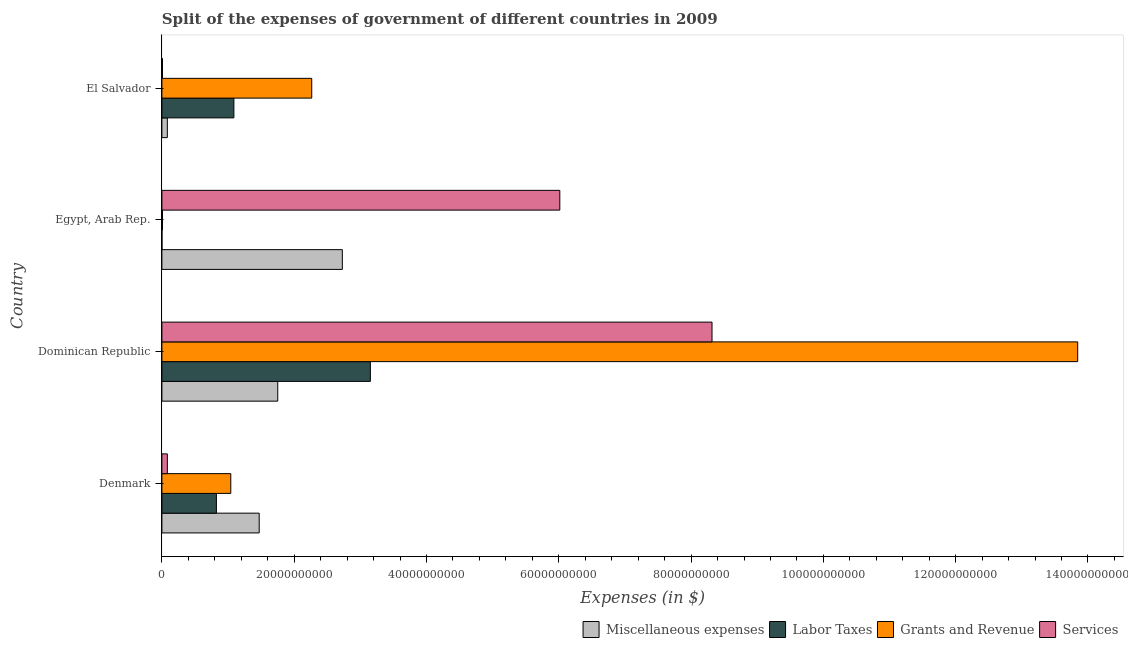How many groups of bars are there?
Make the answer very short. 4. Are the number of bars on each tick of the Y-axis equal?
Give a very brief answer. Yes. How many bars are there on the 2nd tick from the top?
Provide a short and direct response. 4. How many bars are there on the 2nd tick from the bottom?
Make the answer very short. 4. What is the label of the 2nd group of bars from the top?
Offer a very short reply. Egypt, Arab Rep. What is the amount spent on services in Dominican Republic?
Your answer should be very brief. 8.32e+1. Across all countries, what is the maximum amount spent on grants and revenue?
Give a very brief answer. 1.38e+11. Across all countries, what is the minimum amount spent on services?
Keep it short and to the point. 8.44e+07. In which country was the amount spent on services maximum?
Your answer should be compact. Dominican Republic. In which country was the amount spent on labor taxes minimum?
Your answer should be very brief. Egypt, Arab Rep. What is the total amount spent on services in the graph?
Your answer should be compact. 1.44e+11. What is the difference between the amount spent on grants and revenue in Denmark and that in El Salvador?
Make the answer very short. -1.22e+1. What is the difference between the amount spent on services in Dominican Republic and the amount spent on miscellaneous expenses in El Salvador?
Make the answer very short. 8.23e+1. What is the average amount spent on grants and revenue per country?
Keep it short and to the point. 4.29e+1. What is the difference between the amount spent on grants and revenue and amount spent on miscellaneous expenses in Denmark?
Keep it short and to the point. -4.30e+09. What is the ratio of the amount spent on grants and revenue in Dominican Republic to that in Egypt, Arab Rep.?
Your response must be concise. 1518.04. Is the amount spent on services in Denmark less than that in El Salvador?
Offer a terse response. No. What is the difference between the highest and the second highest amount spent on labor taxes?
Offer a terse response. 2.06e+1. What is the difference between the highest and the lowest amount spent on miscellaneous expenses?
Offer a terse response. 2.65e+1. In how many countries, is the amount spent on miscellaneous expenses greater than the average amount spent on miscellaneous expenses taken over all countries?
Give a very brief answer. 2. Is the sum of the amount spent on services in Denmark and El Salvador greater than the maximum amount spent on miscellaneous expenses across all countries?
Your response must be concise. No. Is it the case that in every country, the sum of the amount spent on grants and revenue and amount spent on services is greater than the sum of amount spent on labor taxes and amount spent on miscellaneous expenses?
Your response must be concise. No. What does the 1st bar from the top in Denmark represents?
Your answer should be compact. Services. What does the 2nd bar from the bottom in Dominican Republic represents?
Provide a succinct answer. Labor Taxes. What is the difference between two consecutive major ticks on the X-axis?
Your answer should be compact. 2.00e+1. Does the graph contain any zero values?
Provide a succinct answer. No. Does the graph contain grids?
Provide a succinct answer. No. Where does the legend appear in the graph?
Make the answer very short. Bottom right. How are the legend labels stacked?
Your response must be concise. Horizontal. What is the title of the graph?
Your response must be concise. Split of the expenses of government of different countries in 2009. Does "Overall level" appear as one of the legend labels in the graph?
Provide a short and direct response. No. What is the label or title of the X-axis?
Make the answer very short. Expenses (in $). What is the label or title of the Y-axis?
Make the answer very short. Country. What is the Expenses (in $) in Miscellaneous expenses in Denmark?
Offer a very short reply. 1.47e+1. What is the Expenses (in $) in Labor Taxes in Denmark?
Your answer should be compact. 8.24e+09. What is the Expenses (in $) of Grants and Revenue in Denmark?
Ensure brevity in your answer.  1.04e+1. What is the Expenses (in $) in Services in Denmark?
Provide a short and direct response. 8.23e+08. What is the Expenses (in $) of Miscellaneous expenses in Dominican Republic?
Give a very brief answer. 1.75e+1. What is the Expenses (in $) in Labor Taxes in Dominican Republic?
Make the answer very short. 3.15e+1. What is the Expenses (in $) of Grants and Revenue in Dominican Republic?
Provide a succinct answer. 1.38e+11. What is the Expenses (in $) in Services in Dominican Republic?
Offer a terse response. 8.32e+1. What is the Expenses (in $) in Miscellaneous expenses in Egypt, Arab Rep.?
Give a very brief answer. 2.73e+1. What is the Expenses (in $) of Labor Taxes in Egypt, Arab Rep.?
Provide a succinct answer. 9.10e+06. What is the Expenses (in $) of Grants and Revenue in Egypt, Arab Rep.?
Provide a succinct answer. 9.12e+07. What is the Expenses (in $) in Services in Egypt, Arab Rep.?
Provide a short and direct response. 6.02e+1. What is the Expenses (in $) in Miscellaneous expenses in El Salvador?
Provide a succinct answer. 8.19e+08. What is the Expenses (in $) in Labor Taxes in El Salvador?
Provide a short and direct response. 1.09e+1. What is the Expenses (in $) of Grants and Revenue in El Salvador?
Keep it short and to the point. 2.26e+1. What is the Expenses (in $) in Services in El Salvador?
Ensure brevity in your answer.  8.44e+07. Across all countries, what is the maximum Expenses (in $) of Miscellaneous expenses?
Offer a terse response. 2.73e+1. Across all countries, what is the maximum Expenses (in $) of Labor Taxes?
Make the answer very short. 3.15e+1. Across all countries, what is the maximum Expenses (in $) in Grants and Revenue?
Give a very brief answer. 1.38e+11. Across all countries, what is the maximum Expenses (in $) of Services?
Keep it short and to the point. 8.32e+1. Across all countries, what is the minimum Expenses (in $) in Miscellaneous expenses?
Give a very brief answer. 8.19e+08. Across all countries, what is the minimum Expenses (in $) of Labor Taxes?
Your answer should be very brief. 9.10e+06. Across all countries, what is the minimum Expenses (in $) of Grants and Revenue?
Give a very brief answer. 9.12e+07. Across all countries, what is the minimum Expenses (in $) in Services?
Your answer should be compact. 8.44e+07. What is the total Expenses (in $) in Miscellaneous expenses in the graph?
Make the answer very short. 6.03e+1. What is the total Expenses (in $) in Labor Taxes in the graph?
Keep it short and to the point. 5.06e+1. What is the total Expenses (in $) in Grants and Revenue in the graph?
Offer a terse response. 1.72e+11. What is the total Expenses (in $) in Services in the graph?
Provide a succinct answer. 1.44e+11. What is the difference between the Expenses (in $) in Miscellaneous expenses in Denmark and that in Dominican Republic?
Offer a very short reply. -2.80e+09. What is the difference between the Expenses (in $) of Labor Taxes in Denmark and that in Dominican Republic?
Give a very brief answer. -2.33e+1. What is the difference between the Expenses (in $) of Grants and Revenue in Denmark and that in Dominican Republic?
Offer a terse response. -1.28e+11. What is the difference between the Expenses (in $) of Services in Denmark and that in Dominican Republic?
Give a very brief answer. -8.23e+1. What is the difference between the Expenses (in $) of Miscellaneous expenses in Denmark and that in Egypt, Arab Rep.?
Ensure brevity in your answer.  -1.26e+1. What is the difference between the Expenses (in $) of Labor Taxes in Denmark and that in Egypt, Arab Rep.?
Ensure brevity in your answer.  8.23e+09. What is the difference between the Expenses (in $) of Grants and Revenue in Denmark and that in Egypt, Arab Rep.?
Offer a terse response. 1.03e+1. What is the difference between the Expenses (in $) of Services in Denmark and that in Egypt, Arab Rep.?
Ensure brevity in your answer.  -5.93e+1. What is the difference between the Expenses (in $) in Miscellaneous expenses in Denmark and that in El Salvador?
Give a very brief answer. 1.39e+1. What is the difference between the Expenses (in $) of Labor Taxes in Denmark and that in El Salvador?
Keep it short and to the point. -2.64e+09. What is the difference between the Expenses (in $) of Grants and Revenue in Denmark and that in El Salvador?
Offer a terse response. -1.22e+1. What is the difference between the Expenses (in $) in Services in Denmark and that in El Salvador?
Your answer should be compact. 7.39e+08. What is the difference between the Expenses (in $) in Miscellaneous expenses in Dominican Republic and that in Egypt, Arab Rep.?
Keep it short and to the point. -9.76e+09. What is the difference between the Expenses (in $) of Labor Taxes in Dominican Republic and that in Egypt, Arab Rep.?
Your answer should be very brief. 3.15e+1. What is the difference between the Expenses (in $) in Grants and Revenue in Dominican Republic and that in Egypt, Arab Rep.?
Provide a short and direct response. 1.38e+11. What is the difference between the Expenses (in $) in Services in Dominican Republic and that in Egypt, Arab Rep.?
Your answer should be compact. 2.30e+1. What is the difference between the Expenses (in $) in Miscellaneous expenses in Dominican Republic and that in El Salvador?
Your answer should be very brief. 1.67e+1. What is the difference between the Expenses (in $) of Labor Taxes in Dominican Republic and that in El Salvador?
Your answer should be very brief. 2.06e+1. What is the difference between the Expenses (in $) of Grants and Revenue in Dominican Republic and that in El Salvador?
Your response must be concise. 1.16e+11. What is the difference between the Expenses (in $) in Services in Dominican Republic and that in El Salvador?
Ensure brevity in your answer.  8.31e+1. What is the difference between the Expenses (in $) of Miscellaneous expenses in Egypt, Arab Rep. and that in El Salvador?
Give a very brief answer. 2.65e+1. What is the difference between the Expenses (in $) of Labor Taxes in Egypt, Arab Rep. and that in El Salvador?
Offer a very short reply. -1.09e+1. What is the difference between the Expenses (in $) in Grants and Revenue in Egypt, Arab Rep. and that in El Salvador?
Your answer should be compact. -2.26e+1. What is the difference between the Expenses (in $) in Services in Egypt, Arab Rep. and that in El Salvador?
Your response must be concise. 6.01e+1. What is the difference between the Expenses (in $) of Miscellaneous expenses in Denmark and the Expenses (in $) of Labor Taxes in Dominican Republic?
Make the answer very short. -1.68e+1. What is the difference between the Expenses (in $) in Miscellaneous expenses in Denmark and the Expenses (in $) in Grants and Revenue in Dominican Republic?
Provide a short and direct response. -1.24e+11. What is the difference between the Expenses (in $) in Miscellaneous expenses in Denmark and the Expenses (in $) in Services in Dominican Republic?
Ensure brevity in your answer.  -6.85e+1. What is the difference between the Expenses (in $) of Labor Taxes in Denmark and the Expenses (in $) of Grants and Revenue in Dominican Republic?
Offer a very short reply. -1.30e+11. What is the difference between the Expenses (in $) of Labor Taxes in Denmark and the Expenses (in $) of Services in Dominican Republic?
Provide a short and direct response. -7.49e+1. What is the difference between the Expenses (in $) in Grants and Revenue in Denmark and the Expenses (in $) in Services in Dominican Republic?
Your answer should be very brief. -7.28e+1. What is the difference between the Expenses (in $) of Miscellaneous expenses in Denmark and the Expenses (in $) of Labor Taxes in Egypt, Arab Rep.?
Keep it short and to the point. 1.47e+1. What is the difference between the Expenses (in $) of Miscellaneous expenses in Denmark and the Expenses (in $) of Grants and Revenue in Egypt, Arab Rep.?
Give a very brief answer. 1.46e+1. What is the difference between the Expenses (in $) in Miscellaneous expenses in Denmark and the Expenses (in $) in Services in Egypt, Arab Rep.?
Offer a very short reply. -4.54e+1. What is the difference between the Expenses (in $) in Labor Taxes in Denmark and the Expenses (in $) in Grants and Revenue in Egypt, Arab Rep.?
Provide a short and direct response. 8.15e+09. What is the difference between the Expenses (in $) in Labor Taxes in Denmark and the Expenses (in $) in Services in Egypt, Arab Rep.?
Offer a terse response. -5.19e+1. What is the difference between the Expenses (in $) in Grants and Revenue in Denmark and the Expenses (in $) in Services in Egypt, Arab Rep.?
Make the answer very short. -4.97e+1. What is the difference between the Expenses (in $) of Miscellaneous expenses in Denmark and the Expenses (in $) of Labor Taxes in El Salvador?
Offer a terse response. 3.83e+09. What is the difference between the Expenses (in $) in Miscellaneous expenses in Denmark and the Expenses (in $) in Grants and Revenue in El Salvador?
Your response must be concise. -7.94e+09. What is the difference between the Expenses (in $) in Miscellaneous expenses in Denmark and the Expenses (in $) in Services in El Salvador?
Your answer should be compact. 1.46e+1. What is the difference between the Expenses (in $) in Labor Taxes in Denmark and the Expenses (in $) in Grants and Revenue in El Salvador?
Provide a short and direct response. -1.44e+1. What is the difference between the Expenses (in $) of Labor Taxes in Denmark and the Expenses (in $) of Services in El Salvador?
Your answer should be very brief. 8.15e+09. What is the difference between the Expenses (in $) of Grants and Revenue in Denmark and the Expenses (in $) of Services in El Salvador?
Give a very brief answer. 1.03e+1. What is the difference between the Expenses (in $) of Miscellaneous expenses in Dominican Republic and the Expenses (in $) of Labor Taxes in Egypt, Arab Rep.?
Provide a short and direct response. 1.75e+1. What is the difference between the Expenses (in $) of Miscellaneous expenses in Dominican Republic and the Expenses (in $) of Grants and Revenue in Egypt, Arab Rep.?
Offer a terse response. 1.74e+1. What is the difference between the Expenses (in $) in Miscellaneous expenses in Dominican Republic and the Expenses (in $) in Services in Egypt, Arab Rep.?
Your response must be concise. -4.26e+1. What is the difference between the Expenses (in $) in Labor Taxes in Dominican Republic and the Expenses (in $) in Grants and Revenue in Egypt, Arab Rep.?
Your response must be concise. 3.14e+1. What is the difference between the Expenses (in $) of Labor Taxes in Dominican Republic and the Expenses (in $) of Services in Egypt, Arab Rep.?
Provide a succinct answer. -2.86e+1. What is the difference between the Expenses (in $) in Grants and Revenue in Dominican Republic and the Expenses (in $) in Services in Egypt, Arab Rep.?
Your answer should be compact. 7.83e+1. What is the difference between the Expenses (in $) in Miscellaneous expenses in Dominican Republic and the Expenses (in $) in Labor Taxes in El Salvador?
Provide a short and direct response. 6.63e+09. What is the difference between the Expenses (in $) in Miscellaneous expenses in Dominican Republic and the Expenses (in $) in Grants and Revenue in El Salvador?
Make the answer very short. -5.14e+09. What is the difference between the Expenses (in $) in Miscellaneous expenses in Dominican Republic and the Expenses (in $) in Services in El Salvador?
Ensure brevity in your answer.  1.74e+1. What is the difference between the Expenses (in $) in Labor Taxes in Dominican Republic and the Expenses (in $) in Grants and Revenue in El Salvador?
Offer a very short reply. 8.87e+09. What is the difference between the Expenses (in $) in Labor Taxes in Dominican Republic and the Expenses (in $) in Services in El Salvador?
Keep it short and to the point. 3.14e+1. What is the difference between the Expenses (in $) of Grants and Revenue in Dominican Republic and the Expenses (in $) of Services in El Salvador?
Make the answer very short. 1.38e+11. What is the difference between the Expenses (in $) of Miscellaneous expenses in Egypt, Arab Rep. and the Expenses (in $) of Labor Taxes in El Salvador?
Provide a succinct answer. 1.64e+1. What is the difference between the Expenses (in $) of Miscellaneous expenses in Egypt, Arab Rep. and the Expenses (in $) of Grants and Revenue in El Salvador?
Keep it short and to the point. 4.63e+09. What is the difference between the Expenses (in $) in Miscellaneous expenses in Egypt, Arab Rep. and the Expenses (in $) in Services in El Salvador?
Your response must be concise. 2.72e+1. What is the difference between the Expenses (in $) in Labor Taxes in Egypt, Arab Rep. and the Expenses (in $) in Grants and Revenue in El Salvador?
Your response must be concise. -2.26e+1. What is the difference between the Expenses (in $) of Labor Taxes in Egypt, Arab Rep. and the Expenses (in $) of Services in El Salvador?
Provide a short and direct response. -7.53e+07. What is the difference between the Expenses (in $) of Grants and Revenue in Egypt, Arab Rep. and the Expenses (in $) of Services in El Salvador?
Make the answer very short. 6.80e+06. What is the average Expenses (in $) in Miscellaneous expenses per country?
Make the answer very short. 1.51e+1. What is the average Expenses (in $) in Labor Taxes per country?
Keep it short and to the point. 1.27e+1. What is the average Expenses (in $) in Grants and Revenue per country?
Keep it short and to the point. 4.29e+1. What is the average Expenses (in $) in Services per country?
Your answer should be very brief. 3.61e+1. What is the difference between the Expenses (in $) in Miscellaneous expenses and Expenses (in $) in Labor Taxes in Denmark?
Give a very brief answer. 6.47e+09. What is the difference between the Expenses (in $) in Miscellaneous expenses and Expenses (in $) in Grants and Revenue in Denmark?
Ensure brevity in your answer.  4.30e+09. What is the difference between the Expenses (in $) in Miscellaneous expenses and Expenses (in $) in Services in Denmark?
Offer a terse response. 1.39e+1. What is the difference between the Expenses (in $) of Labor Taxes and Expenses (in $) of Grants and Revenue in Denmark?
Give a very brief answer. -2.17e+09. What is the difference between the Expenses (in $) of Labor Taxes and Expenses (in $) of Services in Denmark?
Provide a short and direct response. 7.42e+09. What is the difference between the Expenses (in $) of Grants and Revenue and Expenses (in $) of Services in Denmark?
Offer a very short reply. 9.59e+09. What is the difference between the Expenses (in $) of Miscellaneous expenses and Expenses (in $) of Labor Taxes in Dominican Republic?
Offer a very short reply. -1.40e+1. What is the difference between the Expenses (in $) of Miscellaneous expenses and Expenses (in $) of Grants and Revenue in Dominican Republic?
Your answer should be compact. -1.21e+11. What is the difference between the Expenses (in $) of Miscellaneous expenses and Expenses (in $) of Services in Dominican Republic?
Make the answer very short. -6.57e+1. What is the difference between the Expenses (in $) of Labor Taxes and Expenses (in $) of Grants and Revenue in Dominican Republic?
Give a very brief answer. -1.07e+11. What is the difference between the Expenses (in $) in Labor Taxes and Expenses (in $) in Services in Dominican Republic?
Give a very brief answer. -5.16e+1. What is the difference between the Expenses (in $) in Grants and Revenue and Expenses (in $) in Services in Dominican Republic?
Ensure brevity in your answer.  5.53e+1. What is the difference between the Expenses (in $) in Miscellaneous expenses and Expenses (in $) in Labor Taxes in Egypt, Arab Rep.?
Your answer should be compact. 2.73e+1. What is the difference between the Expenses (in $) of Miscellaneous expenses and Expenses (in $) of Grants and Revenue in Egypt, Arab Rep.?
Make the answer very short. 2.72e+1. What is the difference between the Expenses (in $) in Miscellaneous expenses and Expenses (in $) in Services in Egypt, Arab Rep.?
Your answer should be compact. -3.29e+1. What is the difference between the Expenses (in $) of Labor Taxes and Expenses (in $) of Grants and Revenue in Egypt, Arab Rep.?
Offer a terse response. -8.21e+07. What is the difference between the Expenses (in $) of Labor Taxes and Expenses (in $) of Services in Egypt, Arab Rep.?
Ensure brevity in your answer.  -6.01e+1. What is the difference between the Expenses (in $) of Grants and Revenue and Expenses (in $) of Services in Egypt, Arab Rep.?
Make the answer very short. -6.01e+1. What is the difference between the Expenses (in $) of Miscellaneous expenses and Expenses (in $) of Labor Taxes in El Salvador?
Your response must be concise. -1.01e+1. What is the difference between the Expenses (in $) of Miscellaneous expenses and Expenses (in $) of Grants and Revenue in El Salvador?
Offer a terse response. -2.18e+1. What is the difference between the Expenses (in $) in Miscellaneous expenses and Expenses (in $) in Services in El Salvador?
Offer a terse response. 7.35e+08. What is the difference between the Expenses (in $) of Labor Taxes and Expenses (in $) of Grants and Revenue in El Salvador?
Your response must be concise. -1.18e+1. What is the difference between the Expenses (in $) of Labor Taxes and Expenses (in $) of Services in El Salvador?
Make the answer very short. 1.08e+1. What is the difference between the Expenses (in $) of Grants and Revenue and Expenses (in $) of Services in El Salvador?
Your answer should be compact. 2.26e+1. What is the ratio of the Expenses (in $) in Miscellaneous expenses in Denmark to that in Dominican Republic?
Ensure brevity in your answer.  0.84. What is the ratio of the Expenses (in $) in Labor Taxes in Denmark to that in Dominican Republic?
Provide a short and direct response. 0.26. What is the ratio of the Expenses (in $) in Grants and Revenue in Denmark to that in Dominican Republic?
Your answer should be compact. 0.08. What is the ratio of the Expenses (in $) in Services in Denmark to that in Dominican Republic?
Provide a short and direct response. 0.01. What is the ratio of the Expenses (in $) of Miscellaneous expenses in Denmark to that in Egypt, Arab Rep.?
Your answer should be compact. 0.54. What is the ratio of the Expenses (in $) of Labor Taxes in Denmark to that in Egypt, Arab Rep.?
Give a very brief answer. 905.38. What is the ratio of the Expenses (in $) of Grants and Revenue in Denmark to that in Egypt, Arab Rep.?
Offer a terse response. 114.18. What is the ratio of the Expenses (in $) in Services in Denmark to that in Egypt, Arab Rep.?
Give a very brief answer. 0.01. What is the ratio of the Expenses (in $) in Miscellaneous expenses in Denmark to that in El Salvador?
Ensure brevity in your answer.  17.95. What is the ratio of the Expenses (in $) of Labor Taxes in Denmark to that in El Salvador?
Your answer should be very brief. 0.76. What is the ratio of the Expenses (in $) in Grants and Revenue in Denmark to that in El Salvador?
Make the answer very short. 0.46. What is the ratio of the Expenses (in $) of Services in Denmark to that in El Salvador?
Provide a short and direct response. 9.75. What is the ratio of the Expenses (in $) of Miscellaneous expenses in Dominican Republic to that in Egypt, Arab Rep.?
Your answer should be very brief. 0.64. What is the ratio of the Expenses (in $) of Labor Taxes in Dominican Republic to that in Egypt, Arab Rep.?
Give a very brief answer. 3463.19. What is the ratio of the Expenses (in $) in Grants and Revenue in Dominican Republic to that in Egypt, Arab Rep.?
Give a very brief answer. 1518.04. What is the ratio of the Expenses (in $) in Services in Dominican Republic to that in Egypt, Arab Rep.?
Your answer should be compact. 1.38. What is the ratio of the Expenses (in $) in Miscellaneous expenses in Dominican Republic to that in El Salvador?
Make the answer very short. 21.37. What is the ratio of the Expenses (in $) of Labor Taxes in Dominican Republic to that in El Salvador?
Make the answer very short. 2.9. What is the ratio of the Expenses (in $) in Grants and Revenue in Dominican Republic to that in El Salvador?
Offer a terse response. 6.11. What is the ratio of the Expenses (in $) in Services in Dominican Republic to that in El Salvador?
Your answer should be compact. 985.36. What is the ratio of the Expenses (in $) in Miscellaneous expenses in Egypt, Arab Rep. to that in El Salvador?
Your answer should be compact. 33.29. What is the ratio of the Expenses (in $) in Labor Taxes in Egypt, Arab Rep. to that in El Salvador?
Offer a terse response. 0. What is the ratio of the Expenses (in $) of Grants and Revenue in Egypt, Arab Rep. to that in El Salvador?
Make the answer very short. 0. What is the ratio of the Expenses (in $) in Services in Egypt, Arab Rep. to that in El Salvador?
Offer a terse response. 712.73. What is the difference between the highest and the second highest Expenses (in $) of Miscellaneous expenses?
Give a very brief answer. 9.76e+09. What is the difference between the highest and the second highest Expenses (in $) of Labor Taxes?
Your answer should be very brief. 2.06e+1. What is the difference between the highest and the second highest Expenses (in $) in Grants and Revenue?
Provide a succinct answer. 1.16e+11. What is the difference between the highest and the second highest Expenses (in $) in Services?
Keep it short and to the point. 2.30e+1. What is the difference between the highest and the lowest Expenses (in $) in Miscellaneous expenses?
Keep it short and to the point. 2.65e+1. What is the difference between the highest and the lowest Expenses (in $) of Labor Taxes?
Provide a short and direct response. 3.15e+1. What is the difference between the highest and the lowest Expenses (in $) in Grants and Revenue?
Provide a short and direct response. 1.38e+11. What is the difference between the highest and the lowest Expenses (in $) in Services?
Ensure brevity in your answer.  8.31e+1. 